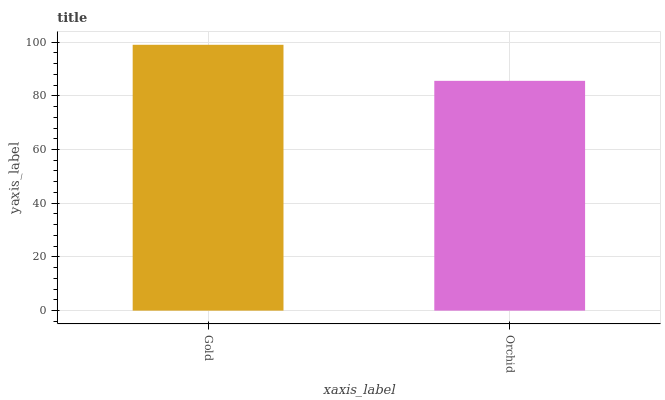Is Orchid the minimum?
Answer yes or no. Yes. Is Gold the maximum?
Answer yes or no. Yes. Is Orchid the maximum?
Answer yes or no. No. Is Gold greater than Orchid?
Answer yes or no. Yes. Is Orchid less than Gold?
Answer yes or no. Yes. Is Orchid greater than Gold?
Answer yes or no. No. Is Gold less than Orchid?
Answer yes or no. No. Is Gold the high median?
Answer yes or no. Yes. Is Orchid the low median?
Answer yes or no. Yes. Is Orchid the high median?
Answer yes or no. No. Is Gold the low median?
Answer yes or no. No. 